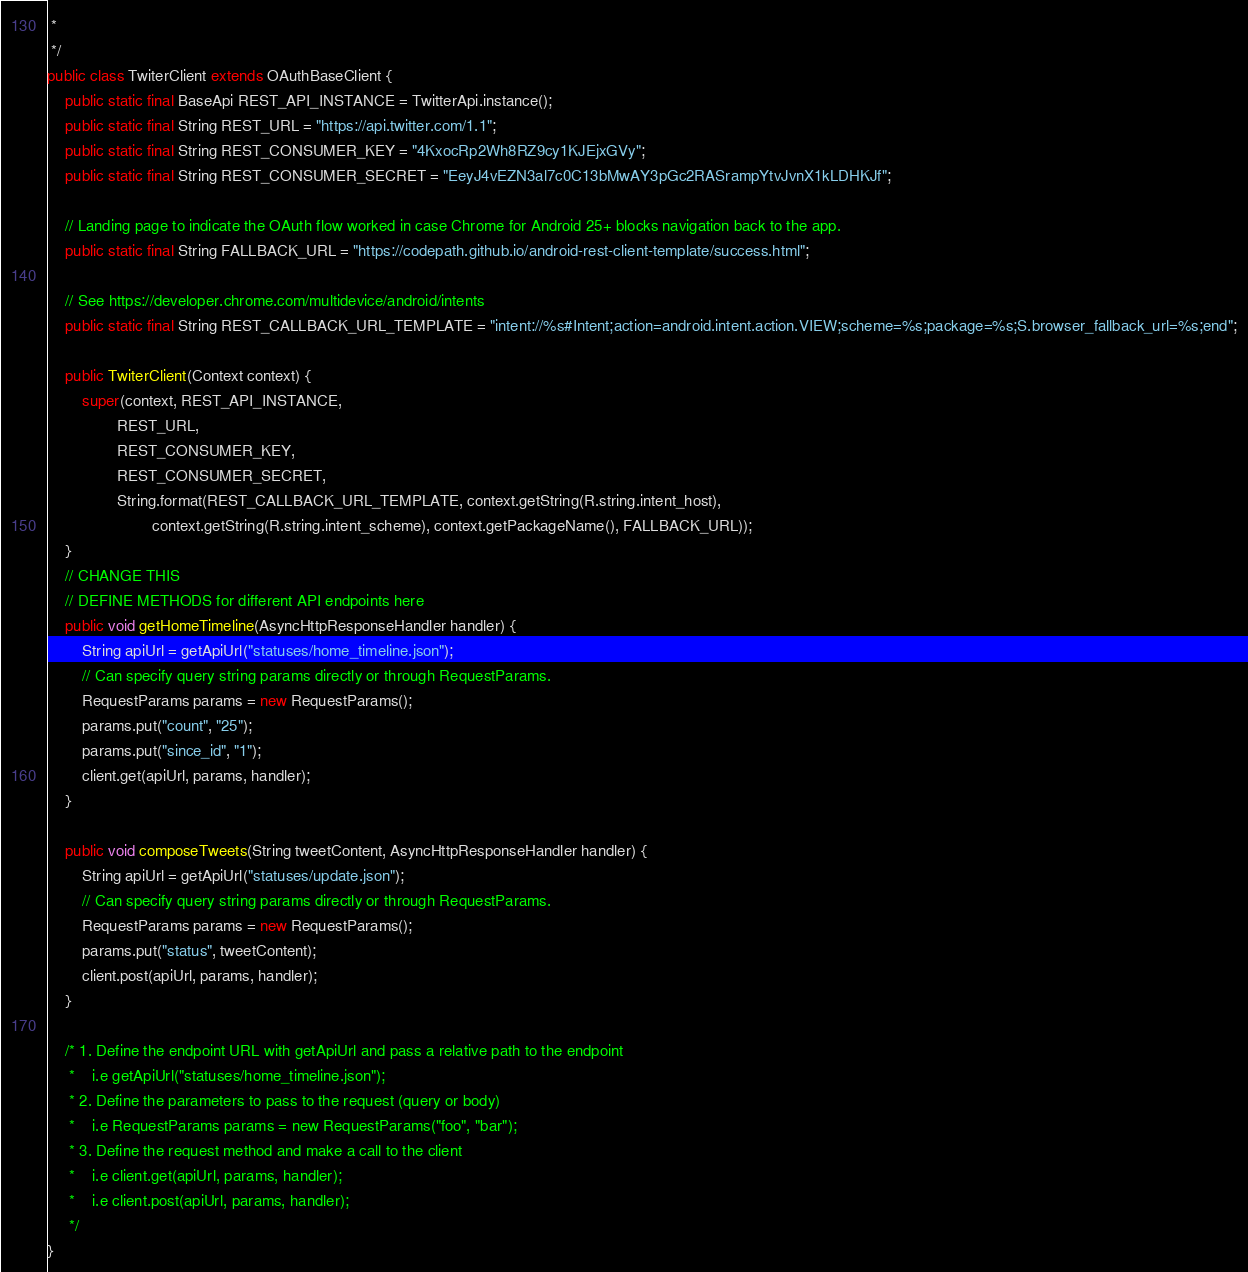Convert code to text. <code><loc_0><loc_0><loc_500><loc_500><_Java_> * 
 */
public class TwiterClient extends OAuthBaseClient {
	public static final BaseApi REST_API_INSTANCE = TwitterApi.instance();
	public static final String REST_URL = "https://api.twitter.com/1.1";
	public static final String REST_CONSUMER_KEY = "4KxocRp2Wh8RZ9cy1KJEjxGVy";
	public static final String REST_CONSUMER_SECRET = "EeyJ4vEZN3al7c0C13bMwAY3pGc2RASrampYtvJvnX1kLDHKJf";

	// Landing page to indicate the OAuth flow worked in case Chrome for Android 25+ blocks navigation back to the app.
	public static final String FALLBACK_URL = "https://codepath.github.io/android-rest-client-template/success.html";

	// See https://developer.chrome.com/multidevice/android/intents
	public static final String REST_CALLBACK_URL_TEMPLATE = "intent://%s#Intent;action=android.intent.action.VIEW;scheme=%s;package=%s;S.browser_fallback_url=%s;end";

	public TwiterClient(Context context) {
		super(context, REST_API_INSTANCE,
				REST_URL,
				REST_CONSUMER_KEY,
				REST_CONSUMER_SECRET,
				String.format(REST_CALLBACK_URL_TEMPLATE, context.getString(R.string.intent_host),
						context.getString(R.string.intent_scheme), context.getPackageName(), FALLBACK_URL));
	}
	// CHANGE THIS
	// DEFINE METHODS for different API endpoints here
	public void getHomeTimeline(AsyncHttpResponseHandler handler) {
		String apiUrl = getApiUrl("statuses/home_timeline.json");
		// Can specify query string params directly or through RequestParams.
		RequestParams params = new RequestParams();
		params.put("count", "25");
		params.put("since_id", "1");
		client.get(apiUrl, params, handler);
	}

	public void composeTweets(String tweetContent, AsyncHttpResponseHandler handler) {
		String apiUrl = getApiUrl("statuses/update.json");
		// Can specify query string params directly or through RequestParams.
		RequestParams params = new RequestParams();
		params.put("status", tweetContent);
		client.post(apiUrl, params, handler);
	}

	/* 1. Define the endpoint URL with getApiUrl and pass a relative path to the endpoint
	 * 	  i.e getApiUrl("statuses/home_timeline.json");
	 * 2. Define the parameters to pass to the request (query or body)
	 *    i.e RequestParams params = new RequestParams("foo", "bar");
	 * 3. Define the request method and make a call to the client
	 *    i.e client.get(apiUrl, params, handler);
	 *    i.e client.post(apiUrl, params, handler);
	 */
}
</code> 